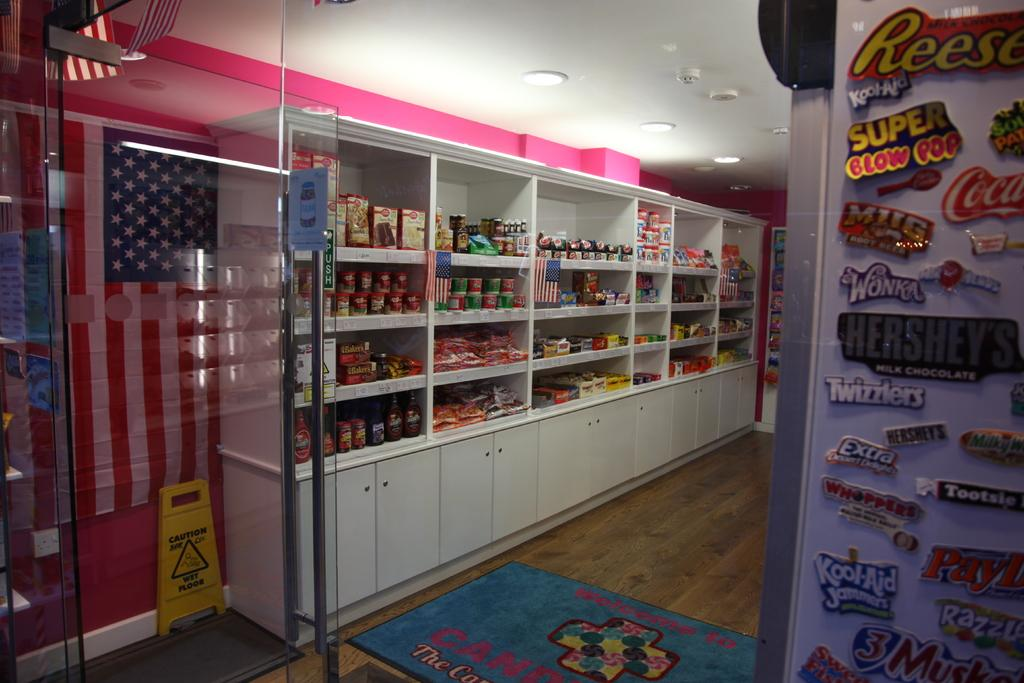<image>
Present a compact description of the photo's key features. Many magnets are on display including one for Twizzlers. 